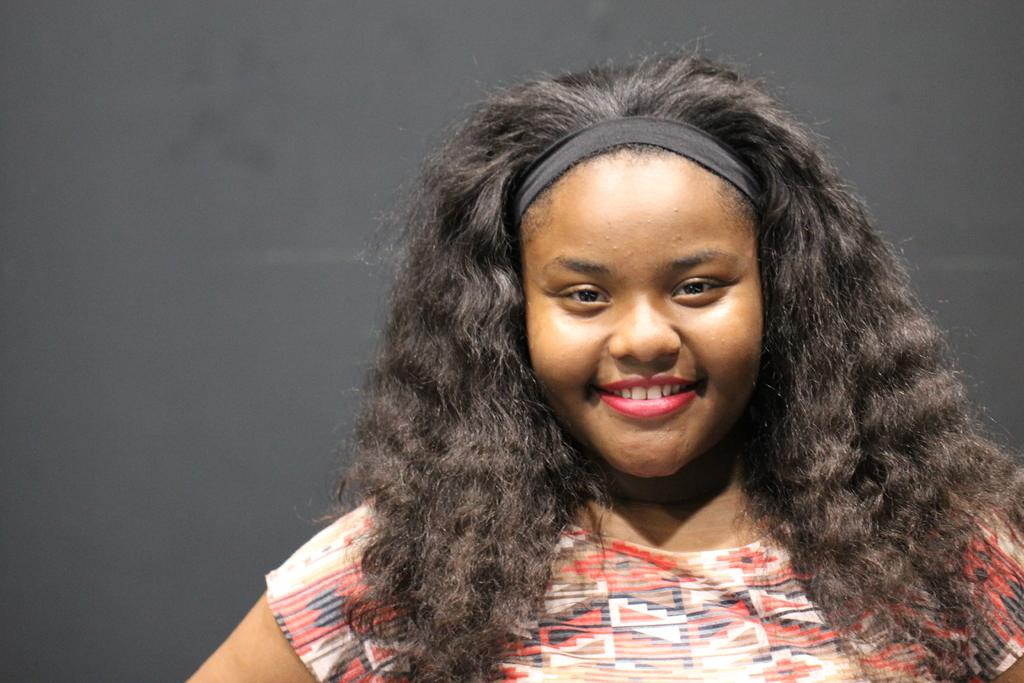Who is the main subject in the image? There is a girl in the center of the image. What is the girl's expression in the image? The girl is smiling in the image. What type of clothing is the girl wearing? The girl is wearing a T-shirt in the image. What can be seen in the background of the image? There is a wall in the background of the image. What flavor of guitar can be seen in the girl's hand in the image? There is no guitar present in the image, and therefore no flavor can be determined. 